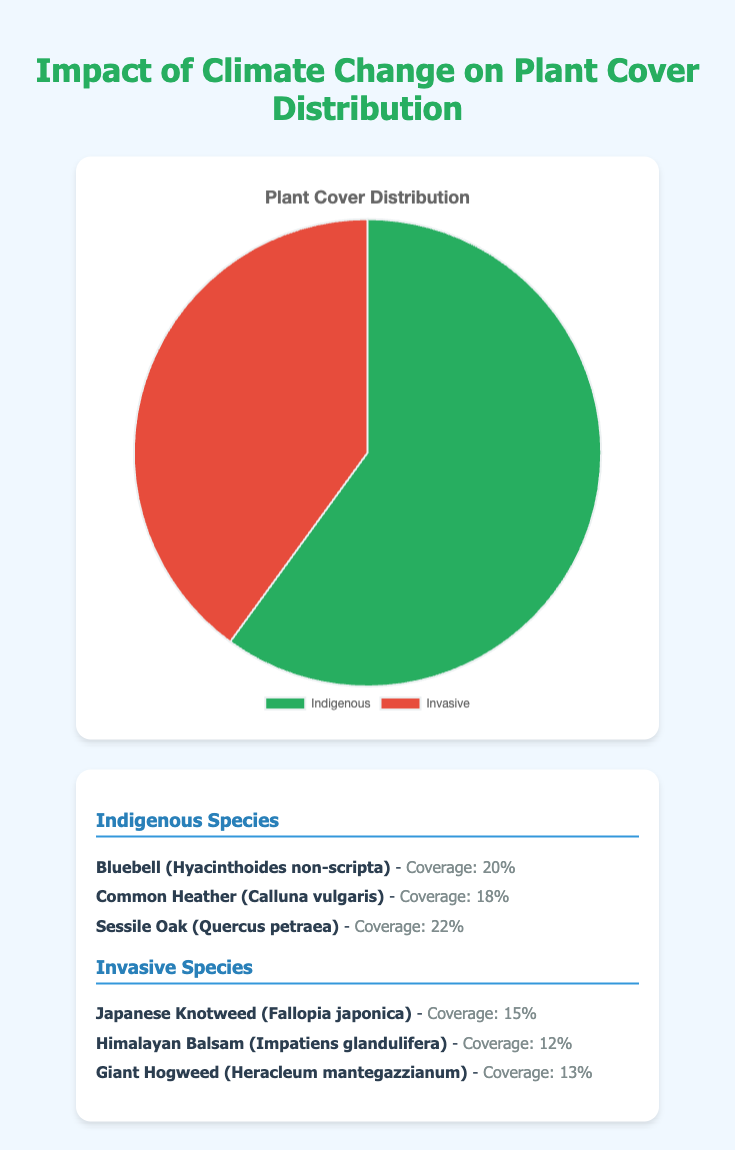What percentage of the overall plant cover is indigenous? The pie chart indicates that 60% of the plant cover is indigenous.
Answer: 60% What are the average coverages of the three invasive species combined? Add the average coverages: Japanese Knotweed (15%) + Himalayan Balsam (12%) + Giant Hogweed (13%) = 40%
Answer: 40% Which type of plant cover (indigenous or invasive) has a higher percentage? The pie chart shows 60% indigenous and 40% invasive, making indigenous higher.
Answer: Indigenous How much larger is the percentage of indigenous plant cover compared to invasive? Indigenous plant cover is 60%. Invasive plant cover is 40%. The difference is 60% - 40% = 20%.
Answer: 20% If the invasive species continue to grow and reach 50%, what would the new percentage of indigenous plant cover be? If invasive cover becomes 50%, the indigenous would be 100% - 50% = 50%.
Answer: 50% How does the average coverage of Sessile Oak compare to that of Japanese Knotweed? Sessile Oak has an average coverage of 22% while Japanese Knotweed has 15%. Sessile Oak's coverage is higher.
Answer: Sessile Oak is higher What is the total percentage of plant cover for Common Heather and Bluebell combined? Add the average coverages: Bluebell (20%) + Common Heather (18%) = 38%
Answer: 38% Which category has the species with the highest average coverage? Indigenous species, with Sessile Oak having 22% average coverage, the highest among all listed species.
Answer: Indigenous What proportion of the total coverage is represented by giant hogweed? Giant Hogweed has an average coverage of 13%. Given the total cover is considered as 100%, the proportion would be 13% / 100% = 13%.
Answer: 13% Are there more plant species sampled in the invasive or indigenous category? Both the indigenous and invasive categories list three species each.
Answer: Both are equal 